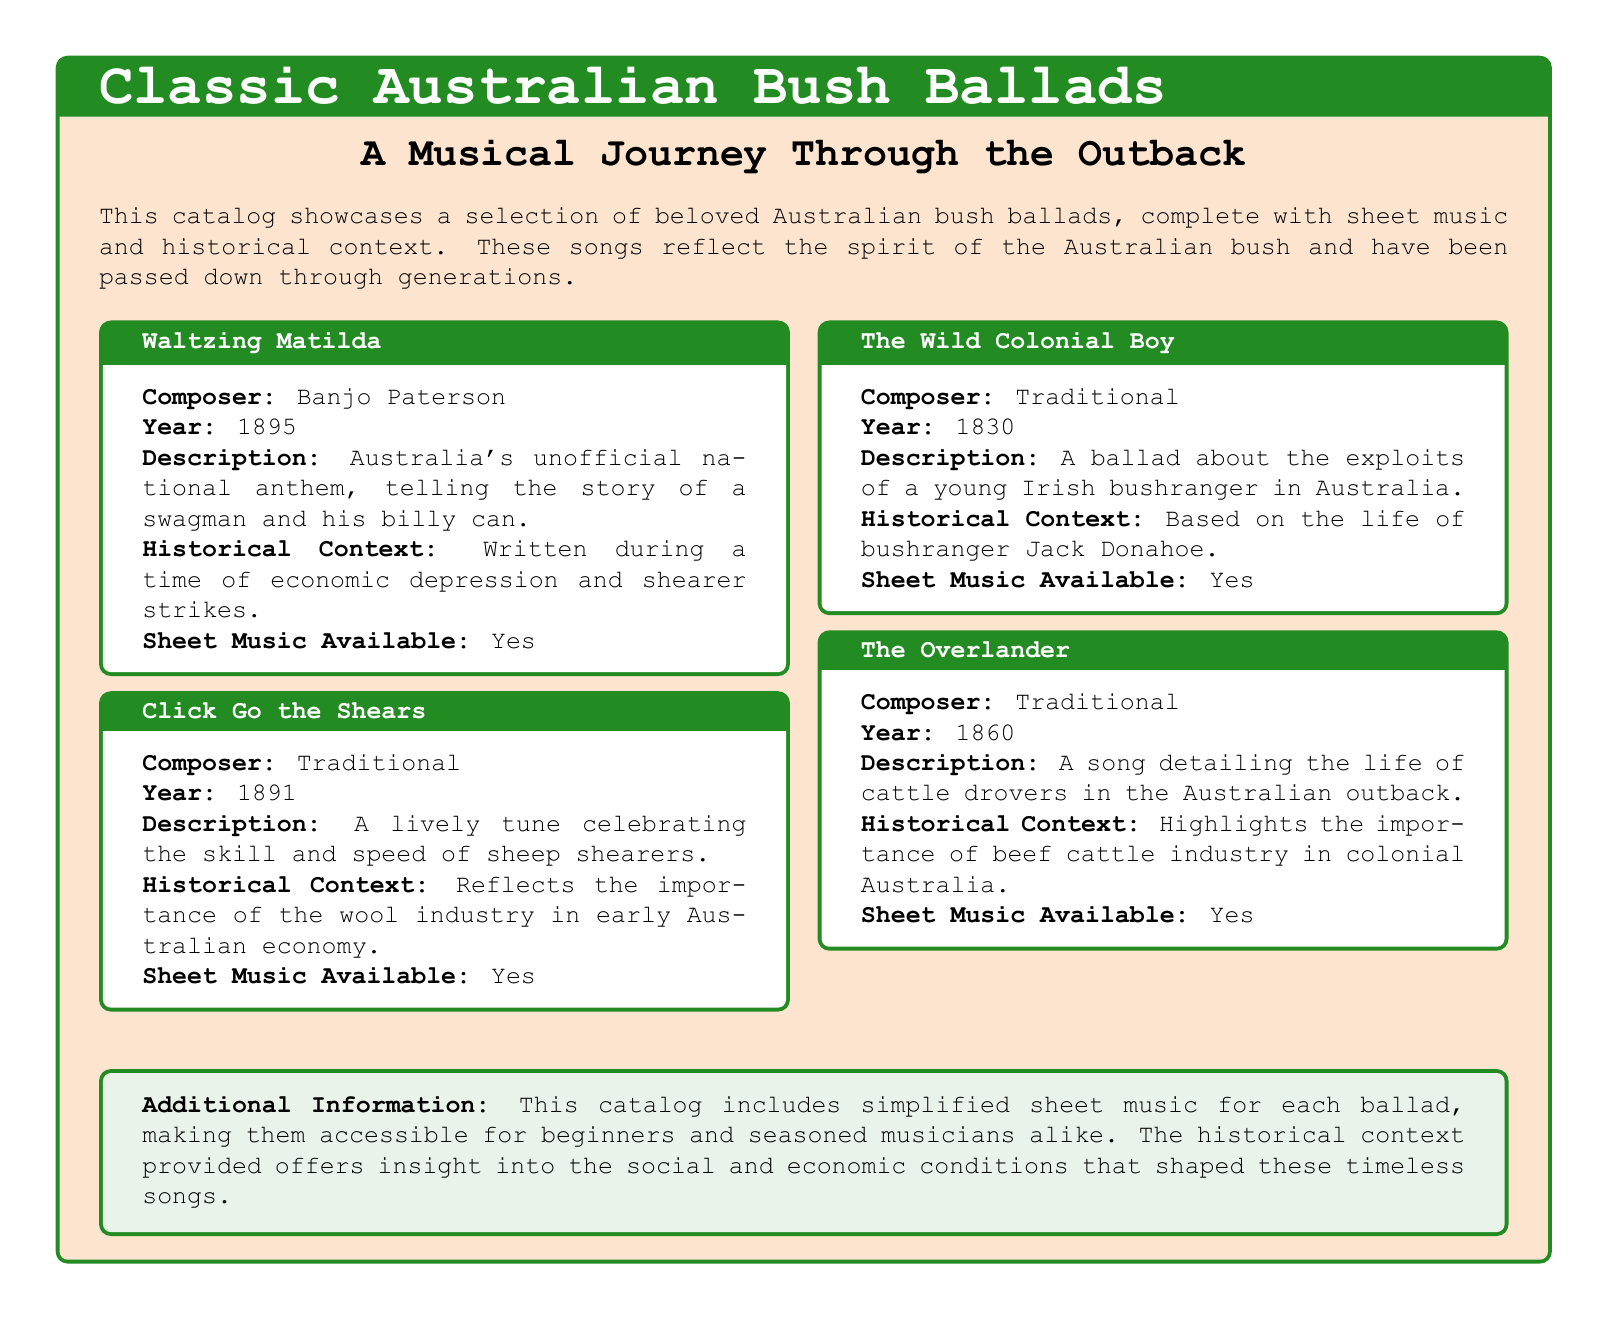What is the title of the first ballad listed? The first ballad listed in the catalog is "Waltzing Matilda."
Answer: Waltzing Matilda Who composed "Click Go the Shears"? The composer of "Click Go the Shears" is listed as Traditional.
Answer: Traditional In what year was "The Wild Colonial Boy" written? The year noted for "The Wild Colonial Boy" is 1830.
Answer: 1830 What is the historical context of "The Overlander"? The historical context mentions the importance of the beef cattle industry in colonial Australia.
Answer: Highlights the importance of beef cattle industry in colonial Australia Is sheet music available for "Waltzing Matilda"? The document confirms that sheet music is available for "Waltzing Matilda."
Answer: Yes Which ballad reflects the importance of the wool industry? "Click Go the Shears" is the ballad that reflects the importance of the wool industry.
Answer: Click Go the Shears What is the main theme of "The Wild Colonial Boy"? The main theme revolves around the exploits of a young Irish bushranger in Australia.
Answer: Exploits of a young Irish bushranger What additional information does the document provide? The additional information highlights that simplified sheet music is included to make the ballads accessible.
Answer: Simplified sheet music available What color is the background of the title box? The background color of the title box is described as sand color.
Answer: Sand color 